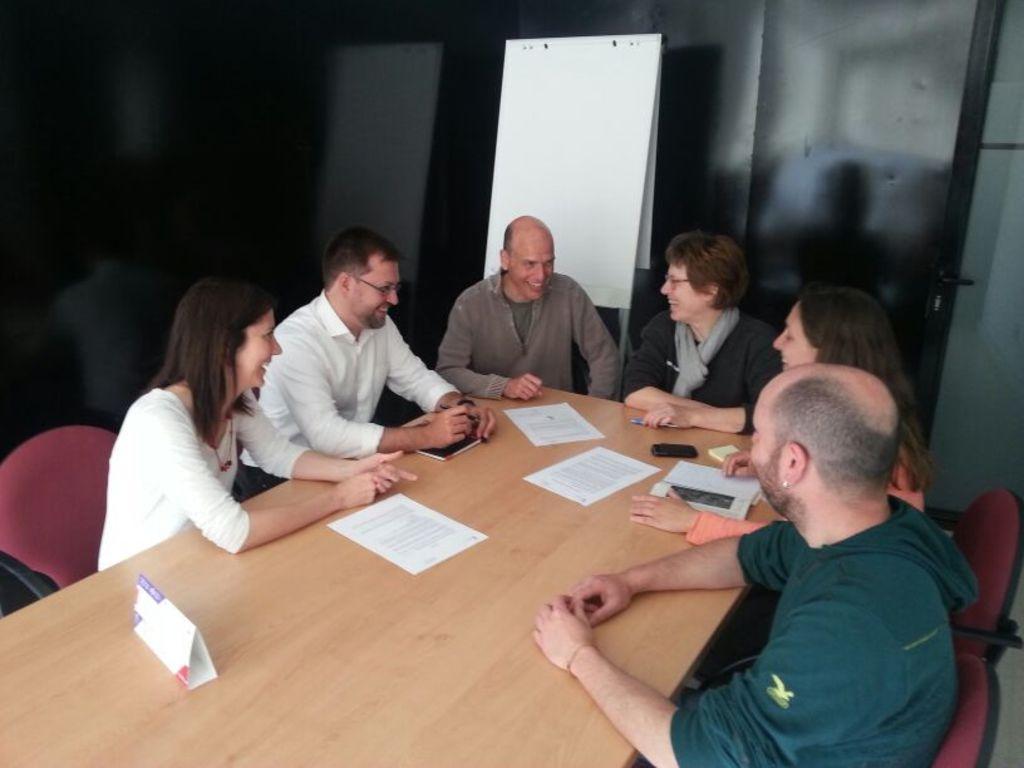How would you summarize this image in a sentence or two? In the image there are group of people sitting on chair in front of a table. On table we can see a paper,book,mobile,pen and a board. In background there is a hoarding and a door which is closed. 